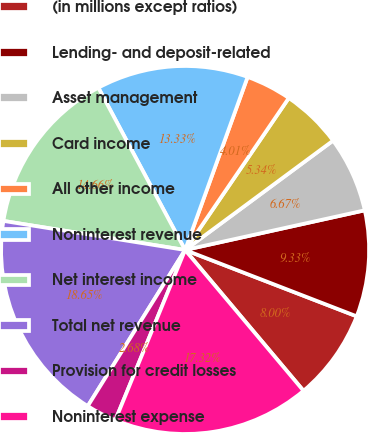Convert chart to OTSL. <chart><loc_0><loc_0><loc_500><loc_500><pie_chart><fcel>(in millions except ratios)<fcel>Lending- and deposit-related<fcel>Asset management<fcel>Card income<fcel>All other income<fcel>Noninterest revenue<fcel>Net interest income<fcel>Total net revenue<fcel>Provision for credit losses<fcel>Noninterest expense<nl><fcel>8.0%<fcel>9.33%<fcel>6.67%<fcel>5.34%<fcel>4.01%<fcel>13.33%<fcel>14.66%<fcel>18.65%<fcel>2.68%<fcel>17.32%<nl></chart> 